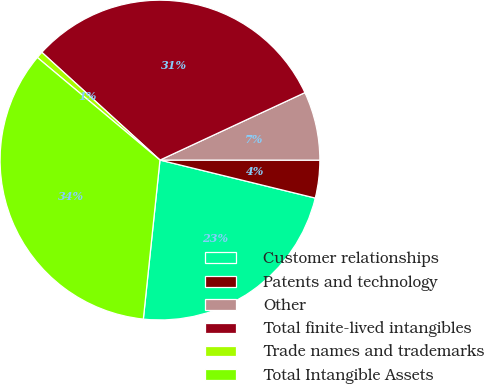Convert chart. <chart><loc_0><loc_0><loc_500><loc_500><pie_chart><fcel>Customer relationships<fcel>Patents and technology<fcel>Other<fcel>Total finite-lived intangibles<fcel>Trade names and trademarks<fcel>Total Intangible Assets<nl><fcel>22.84%<fcel>3.81%<fcel>6.94%<fcel>31.3%<fcel>0.68%<fcel>34.43%<nl></chart> 